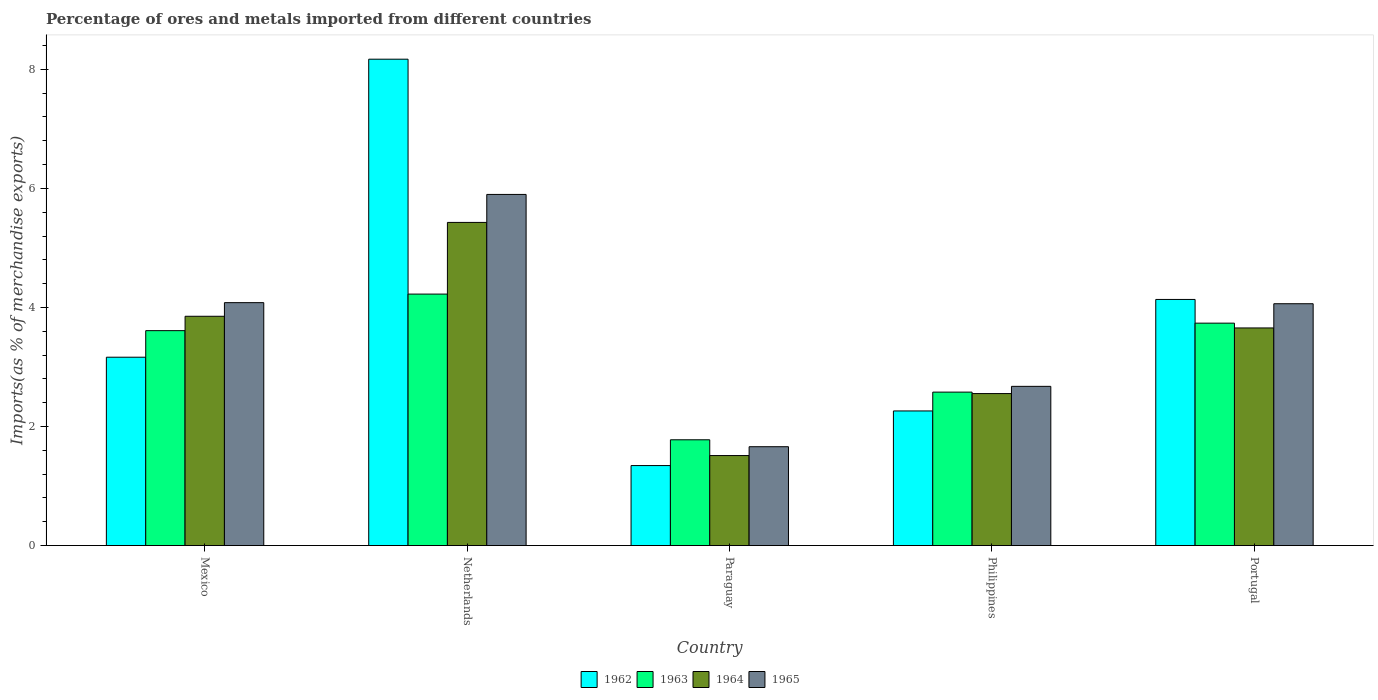How many different coloured bars are there?
Give a very brief answer. 4. How many groups of bars are there?
Offer a terse response. 5. Are the number of bars per tick equal to the number of legend labels?
Your answer should be compact. Yes. How many bars are there on the 1st tick from the right?
Keep it short and to the point. 4. What is the label of the 1st group of bars from the left?
Your answer should be very brief. Mexico. What is the percentage of imports to different countries in 1963 in Portugal?
Make the answer very short. 3.74. Across all countries, what is the maximum percentage of imports to different countries in 1963?
Keep it short and to the point. 4.22. Across all countries, what is the minimum percentage of imports to different countries in 1963?
Your answer should be very brief. 1.78. In which country was the percentage of imports to different countries in 1964 maximum?
Your response must be concise. Netherlands. In which country was the percentage of imports to different countries in 1963 minimum?
Keep it short and to the point. Paraguay. What is the total percentage of imports to different countries in 1964 in the graph?
Your answer should be very brief. 17. What is the difference between the percentage of imports to different countries in 1964 in Mexico and that in Paraguay?
Keep it short and to the point. 2.34. What is the difference between the percentage of imports to different countries in 1965 in Philippines and the percentage of imports to different countries in 1964 in Netherlands?
Offer a very short reply. -2.75. What is the average percentage of imports to different countries in 1965 per country?
Keep it short and to the point. 3.68. What is the difference between the percentage of imports to different countries of/in 1962 and percentage of imports to different countries of/in 1963 in Philippines?
Your answer should be very brief. -0.32. In how many countries, is the percentage of imports to different countries in 1964 greater than 4.8 %?
Your answer should be very brief. 1. What is the ratio of the percentage of imports to different countries in 1963 in Mexico to that in Paraguay?
Your answer should be compact. 2.03. Is the percentage of imports to different countries in 1963 in Netherlands less than that in Paraguay?
Offer a terse response. No. What is the difference between the highest and the second highest percentage of imports to different countries in 1965?
Make the answer very short. -0.02. What is the difference between the highest and the lowest percentage of imports to different countries in 1964?
Make the answer very short. 3.92. In how many countries, is the percentage of imports to different countries in 1962 greater than the average percentage of imports to different countries in 1962 taken over all countries?
Make the answer very short. 2. Is the sum of the percentage of imports to different countries in 1964 in Paraguay and Philippines greater than the maximum percentage of imports to different countries in 1962 across all countries?
Offer a terse response. No. What does the 4th bar from the left in Mexico represents?
Your response must be concise. 1965. What does the 2nd bar from the right in Netherlands represents?
Make the answer very short. 1964. Is it the case that in every country, the sum of the percentage of imports to different countries in 1962 and percentage of imports to different countries in 1964 is greater than the percentage of imports to different countries in 1963?
Keep it short and to the point. Yes. Are all the bars in the graph horizontal?
Make the answer very short. No. Are the values on the major ticks of Y-axis written in scientific E-notation?
Keep it short and to the point. No. Where does the legend appear in the graph?
Your answer should be very brief. Bottom center. What is the title of the graph?
Offer a terse response. Percentage of ores and metals imported from different countries. Does "2000" appear as one of the legend labels in the graph?
Offer a terse response. No. What is the label or title of the X-axis?
Provide a short and direct response. Country. What is the label or title of the Y-axis?
Provide a succinct answer. Imports(as % of merchandise exports). What is the Imports(as % of merchandise exports) in 1962 in Mexico?
Offer a very short reply. 3.16. What is the Imports(as % of merchandise exports) of 1963 in Mexico?
Provide a succinct answer. 3.61. What is the Imports(as % of merchandise exports) of 1964 in Mexico?
Offer a very short reply. 3.85. What is the Imports(as % of merchandise exports) of 1965 in Mexico?
Your response must be concise. 4.08. What is the Imports(as % of merchandise exports) in 1962 in Netherlands?
Provide a short and direct response. 8.17. What is the Imports(as % of merchandise exports) of 1963 in Netherlands?
Offer a terse response. 4.22. What is the Imports(as % of merchandise exports) of 1964 in Netherlands?
Keep it short and to the point. 5.43. What is the Imports(as % of merchandise exports) of 1965 in Netherlands?
Keep it short and to the point. 5.9. What is the Imports(as % of merchandise exports) in 1962 in Paraguay?
Make the answer very short. 1.34. What is the Imports(as % of merchandise exports) of 1963 in Paraguay?
Your answer should be very brief. 1.78. What is the Imports(as % of merchandise exports) of 1964 in Paraguay?
Your answer should be very brief. 1.51. What is the Imports(as % of merchandise exports) in 1965 in Paraguay?
Keep it short and to the point. 1.66. What is the Imports(as % of merchandise exports) of 1962 in Philippines?
Your answer should be compact. 2.26. What is the Imports(as % of merchandise exports) of 1963 in Philippines?
Offer a very short reply. 2.58. What is the Imports(as % of merchandise exports) of 1964 in Philippines?
Provide a succinct answer. 2.55. What is the Imports(as % of merchandise exports) of 1965 in Philippines?
Ensure brevity in your answer.  2.67. What is the Imports(as % of merchandise exports) in 1962 in Portugal?
Provide a succinct answer. 4.13. What is the Imports(as % of merchandise exports) of 1963 in Portugal?
Your answer should be compact. 3.74. What is the Imports(as % of merchandise exports) in 1964 in Portugal?
Offer a very short reply. 3.66. What is the Imports(as % of merchandise exports) of 1965 in Portugal?
Your answer should be compact. 4.06. Across all countries, what is the maximum Imports(as % of merchandise exports) in 1962?
Offer a terse response. 8.17. Across all countries, what is the maximum Imports(as % of merchandise exports) in 1963?
Make the answer very short. 4.22. Across all countries, what is the maximum Imports(as % of merchandise exports) of 1964?
Your answer should be very brief. 5.43. Across all countries, what is the maximum Imports(as % of merchandise exports) in 1965?
Offer a terse response. 5.9. Across all countries, what is the minimum Imports(as % of merchandise exports) of 1962?
Provide a short and direct response. 1.34. Across all countries, what is the minimum Imports(as % of merchandise exports) of 1963?
Offer a very short reply. 1.78. Across all countries, what is the minimum Imports(as % of merchandise exports) in 1964?
Make the answer very short. 1.51. Across all countries, what is the minimum Imports(as % of merchandise exports) in 1965?
Provide a succinct answer. 1.66. What is the total Imports(as % of merchandise exports) in 1962 in the graph?
Provide a succinct answer. 19.08. What is the total Imports(as % of merchandise exports) of 1963 in the graph?
Your answer should be compact. 15.93. What is the total Imports(as % of merchandise exports) in 1964 in the graph?
Give a very brief answer. 17. What is the total Imports(as % of merchandise exports) of 1965 in the graph?
Provide a succinct answer. 18.38. What is the difference between the Imports(as % of merchandise exports) in 1962 in Mexico and that in Netherlands?
Offer a terse response. -5.01. What is the difference between the Imports(as % of merchandise exports) of 1963 in Mexico and that in Netherlands?
Make the answer very short. -0.61. What is the difference between the Imports(as % of merchandise exports) in 1964 in Mexico and that in Netherlands?
Provide a succinct answer. -1.58. What is the difference between the Imports(as % of merchandise exports) of 1965 in Mexico and that in Netherlands?
Ensure brevity in your answer.  -1.82. What is the difference between the Imports(as % of merchandise exports) of 1962 in Mexico and that in Paraguay?
Your answer should be compact. 1.82. What is the difference between the Imports(as % of merchandise exports) in 1963 in Mexico and that in Paraguay?
Make the answer very short. 1.83. What is the difference between the Imports(as % of merchandise exports) of 1964 in Mexico and that in Paraguay?
Provide a succinct answer. 2.34. What is the difference between the Imports(as % of merchandise exports) in 1965 in Mexico and that in Paraguay?
Provide a succinct answer. 2.42. What is the difference between the Imports(as % of merchandise exports) in 1962 in Mexico and that in Philippines?
Offer a very short reply. 0.9. What is the difference between the Imports(as % of merchandise exports) in 1963 in Mexico and that in Philippines?
Offer a very short reply. 1.03. What is the difference between the Imports(as % of merchandise exports) in 1964 in Mexico and that in Philippines?
Make the answer very short. 1.3. What is the difference between the Imports(as % of merchandise exports) in 1965 in Mexico and that in Philippines?
Offer a terse response. 1.41. What is the difference between the Imports(as % of merchandise exports) of 1962 in Mexico and that in Portugal?
Your answer should be very brief. -0.97. What is the difference between the Imports(as % of merchandise exports) of 1963 in Mexico and that in Portugal?
Ensure brevity in your answer.  -0.13. What is the difference between the Imports(as % of merchandise exports) of 1964 in Mexico and that in Portugal?
Your answer should be very brief. 0.2. What is the difference between the Imports(as % of merchandise exports) in 1965 in Mexico and that in Portugal?
Provide a succinct answer. 0.02. What is the difference between the Imports(as % of merchandise exports) of 1962 in Netherlands and that in Paraguay?
Provide a succinct answer. 6.83. What is the difference between the Imports(as % of merchandise exports) of 1963 in Netherlands and that in Paraguay?
Keep it short and to the point. 2.45. What is the difference between the Imports(as % of merchandise exports) in 1964 in Netherlands and that in Paraguay?
Give a very brief answer. 3.92. What is the difference between the Imports(as % of merchandise exports) of 1965 in Netherlands and that in Paraguay?
Offer a terse response. 4.24. What is the difference between the Imports(as % of merchandise exports) in 1962 in Netherlands and that in Philippines?
Provide a short and direct response. 5.91. What is the difference between the Imports(as % of merchandise exports) in 1963 in Netherlands and that in Philippines?
Keep it short and to the point. 1.65. What is the difference between the Imports(as % of merchandise exports) of 1964 in Netherlands and that in Philippines?
Provide a succinct answer. 2.88. What is the difference between the Imports(as % of merchandise exports) in 1965 in Netherlands and that in Philippines?
Keep it short and to the point. 3.22. What is the difference between the Imports(as % of merchandise exports) in 1962 in Netherlands and that in Portugal?
Give a very brief answer. 4.04. What is the difference between the Imports(as % of merchandise exports) in 1963 in Netherlands and that in Portugal?
Your answer should be compact. 0.49. What is the difference between the Imports(as % of merchandise exports) of 1964 in Netherlands and that in Portugal?
Offer a terse response. 1.77. What is the difference between the Imports(as % of merchandise exports) in 1965 in Netherlands and that in Portugal?
Your answer should be compact. 1.84. What is the difference between the Imports(as % of merchandise exports) in 1962 in Paraguay and that in Philippines?
Your answer should be compact. -0.92. What is the difference between the Imports(as % of merchandise exports) of 1963 in Paraguay and that in Philippines?
Provide a short and direct response. -0.8. What is the difference between the Imports(as % of merchandise exports) in 1964 in Paraguay and that in Philippines?
Offer a terse response. -1.04. What is the difference between the Imports(as % of merchandise exports) in 1965 in Paraguay and that in Philippines?
Provide a succinct answer. -1.01. What is the difference between the Imports(as % of merchandise exports) in 1962 in Paraguay and that in Portugal?
Your answer should be very brief. -2.79. What is the difference between the Imports(as % of merchandise exports) of 1963 in Paraguay and that in Portugal?
Offer a very short reply. -1.96. What is the difference between the Imports(as % of merchandise exports) of 1964 in Paraguay and that in Portugal?
Your answer should be very brief. -2.14. What is the difference between the Imports(as % of merchandise exports) of 1965 in Paraguay and that in Portugal?
Provide a succinct answer. -2.4. What is the difference between the Imports(as % of merchandise exports) in 1962 in Philippines and that in Portugal?
Keep it short and to the point. -1.87. What is the difference between the Imports(as % of merchandise exports) of 1963 in Philippines and that in Portugal?
Offer a terse response. -1.16. What is the difference between the Imports(as % of merchandise exports) of 1964 in Philippines and that in Portugal?
Your answer should be compact. -1.1. What is the difference between the Imports(as % of merchandise exports) in 1965 in Philippines and that in Portugal?
Offer a terse response. -1.39. What is the difference between the Imports(as % of merchandise exports) in 1962 in Mexico and the Imports(as % of merchandise exports) in 1963 in Netherlands?
Offer a very short reply. -1.06. What is the difference between the Imports(as % of merchandise exports) in 1962 in Mexico and the Imports(as % of merchandise exports) in 1964 in Netherlands?
Your answer should be very brief. -2.26. What is the difference between the Imports(as % of merchandise exports) of 1962 in Mexico and the Imports(as % of merchandise exports) of 1965 in Netherlands?
Offer a very short reply. -2.73. What is the difference between the Imports(as % of merchandise exports) in 1963 in Mexico and the Imports(as % of merchandise exports) in 1964 in Netherlands?
Ensure brevity in your answer.  -1.82. What is the difference between the Imports(as % of merchandise exports) of 1963 in Mexico and the Imports(as % of merchandise exports) of 1965 in Netherlands?
Make the answer very short. -2.29. What is the difference between the Imports(as % of merchandise exports) in 1964 in Mexico and the Imports(as % of merchandise exports) in 1965 in Netherlands?
Offer a terse response. -2.05. What is the difference between the Imports(as % of merchandise exports) of 1962 in Mexico and the Imports(as % of merchandise exports) of 1963 in Paraguay?
Give a very brief answer. 1.39. What is the difference between the Imports(as % of merchandise exports) in 1962 in Mexico and the Imports(as % of merchandise exports) in 1964 in Paraguay?
Provide a short and direct response. 1.65. What is the difference between the Imports(as % of merchandise exports) in 1962 in Mexico and the Imports(as % of merchandise exports) in 1965 in Paraguay?
Give a very brief answer. 1.5. What is the difference between the Imports(as % of merchandise exports) in 1963 in Mexico and the Imports(as % of merchandise exports) in 1964 in Paraguay?
Offer a very short reply. 2.1. What is the difference between the Imports(as % of merchandise exports) in 1963 in Mexico and the Imports(as % of merchandise exports) in 1965 in Paraguay?
Provide a succinct answer. 1.95. What is the difference between the Imports(as % of merchandise exports) of 1964 in Mexico and the Imports(as % of merchandise exports) of 1965 in Paraguay?
Your answer should be compact. 2.19. What is the difference between the Imports(as % of merchandise exports) in 1962 in Mexico and the Imports(as % of merchandise exports) in 1963 in Philippines?
Make the answer very short. 0.59. What is the difference between the Imports(as % of merchandise exports) of 1962 in Mexico and the Imports(as % of merchandise exports) of 1964 in Philippines?
Offer a very short reply. 0.61. What is the difference between the Imports(as % of merchandise exports) in 1962 in Mexico and the Imports(as % of merchandise exports) in 1965 in Philippines?
Offer a terse response. 0.49. What is the difference between the Imports(as % of merchandise exports) of 1963 in Mexico and the Imports(as % of merchandise exports) of 1964 in Philippines?
Offer a terse response. 1.06. What is the difference between the Imports(as % of merchandise exports) of 1963 in Mexico and the Imports(as % of merchandise exports) of 1965 in Philippines?
Your response must be concise. 0.94. What is the difference between the Imports(as % of merchandise exports) in 1964 in Mexico and the Imports(as % of merchandise exports) in 1965 in Philippines?
Keep it short and to the point. 1.18. What is the difference between the Imports(as % of merchandise exports) of 1962 in Mexico and the Imports(as % of merchandise exports) of 1963 in Portugal?
Provide a succinct answer. -0.57. What is the difference between the Imports(as % of merchandise exports) of 1962 in Mexico and the Imports(as % of merchandise exports) of 1964 in Portugal?
Your answer should be very brief. -0.49. What is the difference between the Imports(as % of merchandise exports) in 1962 in Mexico and the Imports(as % of merchandise exports) in 1965 in Portugal?
Your answer should be very brief. -0.9. What is the difference between the Imports(as % of merchandise exports) of 1963 in Mexico and the Imports(as % of merchandise exports) of 1964 in Portugal?
Provide a short and direct response. -0.05. What is the difference between the Imports(as % of merchandise exports) in 1963 in Mexico and the Imports(as % of merchandise exports) in 1965 in Portugal?
Your answer should be very brief. -0.45. What is the difference between the Imports(as % of merchandise exports) in 1964 in Mexico and the Imports(as % of merchandise exports) in 1965 in Portugal?
Provide a short and direct response. -0.21. What is the difference between the Imports(as % of merchandise exports) of 1962 in Netherlands and the Imports(as % of merchandise exports) of 1963 in Paraguay?
Make the answer very short. 6.39. What is the difference between the Imports(as % of merchandise exports) of 1962 in Netherlands and the Imports(as % of merchandise exports) of 1964 in Paraguay?
Offer a terse response. 6.66. What is the difference between the Imports(as % of merchandise exports) of 1962 in Netherlands and the Imports(as % of merchandise exports) of 1965 in Paraguay?
Offer a very short reply. 6.51. What is the difference between the Imports(as % of merchandise exports) of 1963 in Netherlands and the Imports(as % of merchandise exports) of 1964 in Paraguay?
Make the answer very short. 2.71. What is the difference between the Imports(as % of merchandise exports) of 1963 in Netherlands and the Imports(as % of merchandise exports) of 1965 in Paraguay?
Your answer should be compact. 2.56. What is the difference between the Imports(as % of merchandise exports) of 1964 in Netherlands and the Imports(as % of merchandise exports) of 1965 in Paraguay?
Ensure brevity in your answer.  3.77. What is the difference between the Imports(as % of merchandise exports) in 1962 in Netherlands and the Imports(as % of merchandise exports) in 1963 in Philippines?
Make the answer very short. 5.59. What is the difference between the Imports(as % of merchandise exports) of 1962 in Netherlands and the Imports(as % of merchandise exports) of 1964 in Philippines?
Offer a terse response. 5.62. What is the difference between the Imports(as % of merchandise exports) of 1962 in Netherlands and the Imports(as % of merchandise exports) of 1965 in Philippines?
Make the answer very short. 5.5. What is the difference between the Imports(as % of merchandise exports) in 1963 in Netherlands and the Imports(as % of merchandise exports) in 1964 in Philippines?
Your answer should be compact. 1.67. What is the difference between the Imports(as % of merchandise exports) in 1963 in Netherlands and the Imports(as % of merchandise exports) in 1965 in Philippines?
Keep it short and to the point. 1.55. What is the difference between the Imports(as % of merchandise exports) of 1964 in Netherlands and the Imports(as % of merchandise exports) of 1965 in Philippines?
Offer a very short reply. 2.75. What is the difference between the Imports(as % of merchandise exports) of 1962 in Netherlands and the Imports(as % of merchandise exports) of 1963 in Portugal?
Your answer should be compact. 4.43. What is the difference between the Imports(as % of merchandise exports) of 1962 in Netherlands and the Imports(as % of merchandise exports) of 1964 in Portugal?
Give a very brief answer. 4.51. What is the difference between the Imports(as % of merchandise exports) of 1962 in Netherlands and the Imports(as % of merchandise exports) of 1965 in Portugal?
Your response must be concise. 4.11. What is the difference between the Imports(as % of merchandise exports) in 1963 in Netherlands and the Imports(as % of merchandise exports) in 1964 in Portugal?
Give a very brief answer. 0.57. What is the difference between the Imports(as % of merchandise exports) in 1963 in Netherlands and the Imports(as % of merchandise exports) in 1965 in Portugal?
Keep it short and to the point. 0.16. What is the difference between the Imports(as % of merchandise exports) of 1964 in Netherlands and the Imports(as % of merchandise exports) of 1965 in Portugal?
Provide a short and direct response. 1.37. What is the difference between the Imports(as % of merchandise exports) in 1962 in Paraguay and the Imports(as % of merchandise exports) in 1963 in Philippines?
Ensure brevity in your answer.  -1.23. What is the difference between the Imports(as % of merchandise exports) in 1962 in Paraguay and the Imports(as % of merchandise exports) in 1964 in Philippines?
Your answer should be compact. -1.21. What is the difference between the Imports(as % of merchandise exports) of 1962 in Paraguay and the Imports(as % of merchandise exports) of 1965 in Philippines?
Your answer should be compact. -1.33. What is the difference between the Imports(as % of merchandise exports) in 1963 in Paraguay and the Imports(as % of merchandise exports) in 1964 in Philippines?
Offer a very short reply. -0.78. What is the difference between the Imports(as % of merchandise exports) in 1963 in Paraguay and the Imports(as % of merchandise exports) in 1965 in Philippines?
Keep it short and to the point. -0.9. What is the difference between the Imports(as % of merchandise exports) in 1964 in Paraguay and the Imports(as % of merchandise exports) in 1965 in Philippines?
Make the answer very short. -1.16. What is the difference between the Imports(as % of merchandise exports) in 1962 in Paraguay and the Imports(as % of merchandise exports) in 1963 in Portugal?
Your answer should be very brief. -2.39. What is the difference between the Imports(as % of merchandise exports) of 1962 in Paraguay and the Imports(as % of merchandise exports) of 1964 in Portugal?
Your response must be concise. -2.31. What is the difference between the Imports(as % of merchandise exports) in 1962 in Paraguay and the Imports(as % of merchandise exports) in 1965 in Portugal?
Make the answer very short. -2.72. What is the difference between the Imports(as % of merchandise exports) in 1963 in Paraguay and the Imports(as % of merchandise exports) in 1964 in Portugal?
Your answer should be very brief. -1.88. What is the difference between the Imports(as % of merchandise exports) in 1963 in Paraguay and the Imports(as % of merchandise exports) in 1965 in Portugal?
Your answer should be very brief. -2.29. What is the difference between the Imports(as % of merchandise exports) in 1964 in Paraguay and the Imports(as % of merchandise exports) in 1965 in Portugal?
Your answer should be very brief. -2.55. What is the difference between the Imports(as % of merchandise exports) of 1962 in Philippines and the Imports(as % of merchandise exports) of 1963 in Portugal?
Ensure brevity in your answer.  -1.47. What is the difference between the Imports(as % of merchandise exports) in 1962 in Philippines and the Imports(as % of merchandise exports) in 1964 in Portugal?
Make the answer very short. -1.39. What is the difference between the Imports(as % of merchandise exports) in 1962 in Philippines and the Imports(as % of merchandise exports) in 1965 in Portugal?
Provide a short and direct response. -1.8. What is the difference between the Imports(as % of merchandise exports) in 1963 in Philippines and the Imports(as % of merchandise exports) in 1964 in Portugal?
Your response must be concise. -1.08. What is the difference between the Imports(as % of merchandise exports) of 1963 in Philippines and the Imports(as % of merchandise exports) of 1965 in Portugal?
Your answer should be compact. -1.48. What is the difference between the Imports(as % of merchandise exports) in 1964 in Philippines and the Imports(as % of merchandise exports) in 1965 in Portugal?
Your answer should be very brief. -1.51. What is the average Imports(as % of merchandise exports) of 1962 per country?
Make the answer very short. 3.82. What is the average Imports(as % of merchandise exports) in 1963 per country?
Your answer should be compact. 3.19. What is the average Imports(as % of merchandise exports) in 1964 per country?
Your response must be concise. 3.4. What is the average Imports(as % of merchandise exports) of 1965 per country?
Provide a succinct answer. 3.68. What is the difference between the Imports(as % of merchandise exports) in 1962 and Imports(as % of merchandise exports) in 1963 in Mexico?
Your answer should be compact. -0.45. What is the difference between the Imports(as % of merchandise exports) of 1962 and Imports(as % of merchandise exports) of 1964 in Mexico?
Provide a short and direct response. -0.69. What is the difference between the Imports(as % of merchandise exports) in 1962 and Imports(as % of merchandise exports) in 1965 in Mexico?
Offer a terse response. -0.92. What is the difference between the Imports(as % of merchandise exports) in 1963 and Imports(as % of merchandise exports) in 1964 in Mexico?
Keep it short and to the point. -0.24. What is the difference between the Imports(as % of merchandise exports) of 1963 and Imports(as % of merchandise exports) of 1965 in Mexico?
Make the answer very short. -0.47. What is the difference between the Imports(as % of merchandise exports) of 1964 and Imports(as % of merchandise exports) of 1965 in Mexico?
Provide a succinct answer. -0.23. What is the difference between the Imports(as % of merchandise exports) in 1962 and Imports(as % of merchandise exports) in 1963 in Netherlands?
Provide a succinct answer. 3.95. What is the difference between the Imports(as % of merchandise exports) of 1962 and Imports(as % of merchandise exports) of 1964 in Netherlands?
Give a very brief answer. 2.74. What is the difference between the Imports(as % of merchandise exports) in 1962 and Imports(as % of merchandise exports) in 1965 in Netherlands?
Make the answer very short. 2.27. What is the difference between the Imports(as % of merchandise exports) in 1963 and Imports(as % of merchandise exports) in 1964 in Netherlands?
Offer a very short reply. -1.2. What is the difference between the Imports(as % of merchandise exports) in 1963 and Imports(as % of merchandise exports) in 1965 in Netherlands?
Provide a succinct answer. -1.67. What is the difference between the Imports(as % of merchandise exports) of 1964 and Imports(as % of merchandise exports) of 1965 in Netherlands?
Offer a very short reply. -0.47. What is the difference between the Imports(as % of merchandise exports) of 1962 and Imports(as % of merchandise exports) of 1963 in Paraguay?
Your answer should be compact. -0.43. What is the difference between the Imports(as % of merchandise exports) in 1962 and Imports(as % of merchandise exports) in 1964 in Paraguay?
Provide a short and direct response. -0.17. What is the difference between the Imports(as % of merchandise exports) in 1962 and Imports(as % of merchandise exports) in 1965 in Paraguay?
Ensure brevity in your answer.  -0.32. What is the difference between the Imports(as % of merchandise exports) in 1963 and Imports(as % of merchandise exports) in 1964 in Paraguay?
Offer a terse response. 0.26. What is the difference between the Imports(as % of merchandise exports) in 1963 and Imports(as % of merchandise exports) in 1965 in Paraguay?
Offer a very short reply. 0.12. What is the difference between the Imports(as % of merchandise exports) in 1964 and Imports(as % of merchandise exports) in 1965 in Paraguay?
Give a very brief answer. -0.15. What is the difference between the Imports(as % of merchandise exports) of 1962 and Imports(as % of merchandise exports) of 1963 in Philippines?
Provide a succinct answer. -0.32. What is the difference between the Imports(as % of merchandise exports) of 1962 and Imports(as % of merchandise exports) of 1964 in Philippines?
Ensure brevity in your answer.  -0.29. What is the difference between the Imports(as % of merchandise exports) in 1962 and Imports(as % of merchandise exports) in 1965 in Philippines?
Offer a very short reply. -0.41. What is the difference between the Imports(as % of merchandise exports) in 1963 and Imports(as % of merchandise exports) in 1964 in Philippines?
Your answer should be very brief. 0.02. What is the difference between the Imports(as % of merchandise exports) in 1963 and Imports(as % of merchandise exports) in 1965 in Philippines?
Make the answer very short. -0.1. What is the difference between the Imports(as % of merchandise exports) of 1964 and Imports(as % of merchandise exports) of 1965 in Philippines?
Offer a terse response. -0.12. What is the difference between the Imports(as % of merchandise exports) of 1962 and Imports(as % of merchandise exports) of 1963 in Portugal?
Your answer should be compact. 0.4. What is the difference between the Imports(as % of merchandise exports) of 1962 and Imports(as % of merchandise exports) of 1964 in Portugal?
Offer a very short reply. 0.48. What is the difference between the Imports(as % of merchandise exports) in 1962 and Imports(as % of merchandise exports) in 1965 in Portugal?
Provide a short and direct response. 0.07. What is the difference between the Imports(as % of merchandise exports) of 1963 and Imports(as % of merchandise exports) of 1964 in Portugal?
Keep it short and to the point. 0.08. What is the difference between the Imports(as % of merchandise exports) of 1963 and Imports(as % of merchandise exports) of 1965 in Portugal?
Make the answer very short. -0.33. What is the difference between the Imports(as % of merchandise exports) of 1964 and Imports(as % of merchandise exports) of 1965 in Portugal?
Offer a terse response. -0.41. What is the ratio of the Imports(as % of merchandise exports) of 1962 in Mexico to that in Netherlands?
Your answer should be compact. 0.39. What is the ratio of the Imports(as % of merchandise exports) of 1963 in Mexico to that in Netherlands?
Your answer should be very brief. 0.85. What is the ratio of the Imports(as % of merchandise exports) of 1964 in Mexico to that in Netherlands?
Provide a succinct answer. 0.71. What is the ratio of the Imports(as % of merchandise exports) of 1965 in Mexico to that in Netherlands?
Ensure brevity in your answer.  0.69. What is the ratio of the Imports(as % of merchandise exports) in 1962 in Mexico to that in Paraguay?
Your response must be concise. 2.35. What is the ratio of the Imports(as % of merchandise exports) of 1963 in Mexico to that in Paraguay?
Your answer should be compact. 2.03. What is the ratio of the Imports(as % of merchandise exports) in 1964 in Mexico to that in Paraguay?
Ensure brevity in your answer.  2.55. What is the ratio of the Imports(as % of merchandise exports) of 1965 in Mexico to that in Paraguay?
Ensure brevity in your answer.  2.46. What is the ratio of the Imports(as % of merchandise exports) of 1962 in Mexico to that in Philippines?
Your response must be concise. 1.4. What is the ratio of the Imports(as % of merchandise exports) in 1963 in Mexico to that in Philippines?
Offer a terse response. 1.4. What is the ratio of the Imports(as % of merchandise exports) of 1964 in Mexico to that in Philippines?
Your answer should be very brief. 1.51. What is the ratio of the Imports(as % of merchandise exports) of 1965 in Mexico to that in Philippines?
Make the answer very short. 1.53. What is the ratio of the Imports(as % of merchandise exports) of 1962 in Mexico to that in Portugal?
Offer a very short reply. 0.77. What is the ratio of the Imports(as % of merchandise exports) of 1963 in Mexico to that in Portugal?
Your response must be concise. 0.97. What is the ratio of the Imports(as % of merchandise exports) of 1964 in Mexico to that in Portugal?
Your response must be concise. 1.05. What is the ratio of the Imports(as % of merchandise exports) in 1962 in Netherlands to that in Paraguay?
Make the answer very short. 6.08. What is the ratio of the Imports(as % of merchandise exports) of 1963 in Netherlands to that in Paraguay?
Make the answer very short. 2.38. What is the ratio of the Imports(as % of merchandise exports) of 1964 in Netherlands to that in Paraguay?
Offer a terse response. 3.59. What is the ratio of the Imports(as % of merchandise exports) of 1965 in Netherlands to that in Paraguay?
Keep it short and to the point. 3.55. What is the ratio of the Imports(as % of merchandise exports) of 1962 in Netherlands to that in Philippines?
Offer a terse response. 3.61. What is the ratio of the Imports(as % of merchandise exports) in 1963 in Netherlands to that in Philippines?
Offer a very short reply. 1.64. What is the ratio of the Imports(as % of merchandise exports) of 1964 in Netherlands to that in Philippines?
Keep it short and to the point. 2.13. What is the ratio of the Imports(as % of merchandise exports) of 1965 in Netherlands to that in Philippines?
Your response must be concise. 2.21. What is the ratio of the Imports(as % of merchandise exports) of 1962 in Netherlands to that in Portugal?
Make the answer very short. 1.98. What is the ratio of the Imports(as % of merchandise exports) in 1963 in Netherlands to that in Portugal?
Keep it short and to the point. 1.13. What is the ratio of the Imports(as % of merchandise exports) of 1964 in Netherlands to that in Portugal?
Provide a short and direct response. 1.49. What is the ratio of the Imports(as % of merchandise exports) of 1965 in Netherlands to that in Portugal?
Give a very brief answer. 1.45. What is the ratio of the Imports(as % of merchandise exports) of 1962 in Paraguay to that in Philippines?
Offer a terse response. 0.59. What is the ratio of the Imports(as % of merchandise exports) in 1963 in Paraguay to that in Philippines?
Your answer should be compact. 0.69. What is the ratio of the Imports(as % of merchandise exports) of 1964 in Paraguay to that in Philippines?
Keep it short and to the point. 0.59. What is the ratio of the Imports(as % of merchandise exports) of 1965 in Paraguay to that in Philippines?
Provide a short and direct response. 0.62. What is the ratio of the Imports(as % of merchandise exports) in 1962 in Paraguay to that in Portugal?
Provide a succinct answer. 0.33. What is the ratio of the Imports(as % of merchandise exports) in 1963 in Paraguay to that in Portugal?
Ensure brevity in your answer.  0.48. What is the ratio of the Imports(as % of merchandise exports) of 1964 in Paraguay to that in Portugal?
Offer a terse response. 0.41. What is the ratio of the Imports(as % of merchandise exports) of 1965 in Paraguay to that in Portugal?
Your answer should be compact. 0.41. What is the ratio of the Imports(as % of merchandise exports) in 1962 in Philippines to that in Portugal?
Your response must be concise. 0.55. What is the ratio of the Imports(as % of merchandise exports) of 1963 in Philippines to that in Portugal?
Give a very brief answer. 0.69. What is the ratio of the Imports(as % of merchandise exports) of 1964 in Philippines to that in Portugal?
Your response must be concise. 0.7. What is the ratio of the Imports(as % of merchandise exports) of 1965 in Philippines to that in Portugal?
Offer a terse response. 0.66. What is the difference between the highest and the second highest Imports(as % of merchandise exports) of 1962?
Provide a short and direct response. 4.04. What is the difference between the highest and the second highest Imports(as % of merchandise exports) in 1963?
Your response must be concise. 0.49. What is the difference between the highest and the second highest Imports(as % of merchandise exports) in 1964?
Offer a terse response. 1.58. What is the difference between the highest and the second highest Imports(as % of merchandise exports) in 1965?
Your answer should be very brief. 1.82. What is the difference between the highest and the lowest Imports(as % of merchandise exports) in 1962?
Your response must be concise. 6.83. What is the difference between the highest and the lowest Imports(as % of merchandise exports) in 1963?
Your answer should be compact. 2.45. What is the difference between the highest and the lowest Imports(as % of merchandise exports) of 1964?
Your answer should be compact. 3.92. What is the difference between the highest and the lowest Imports(as % of merchandise exports) of 1965?
Provide a succinct answer. 4.24. 